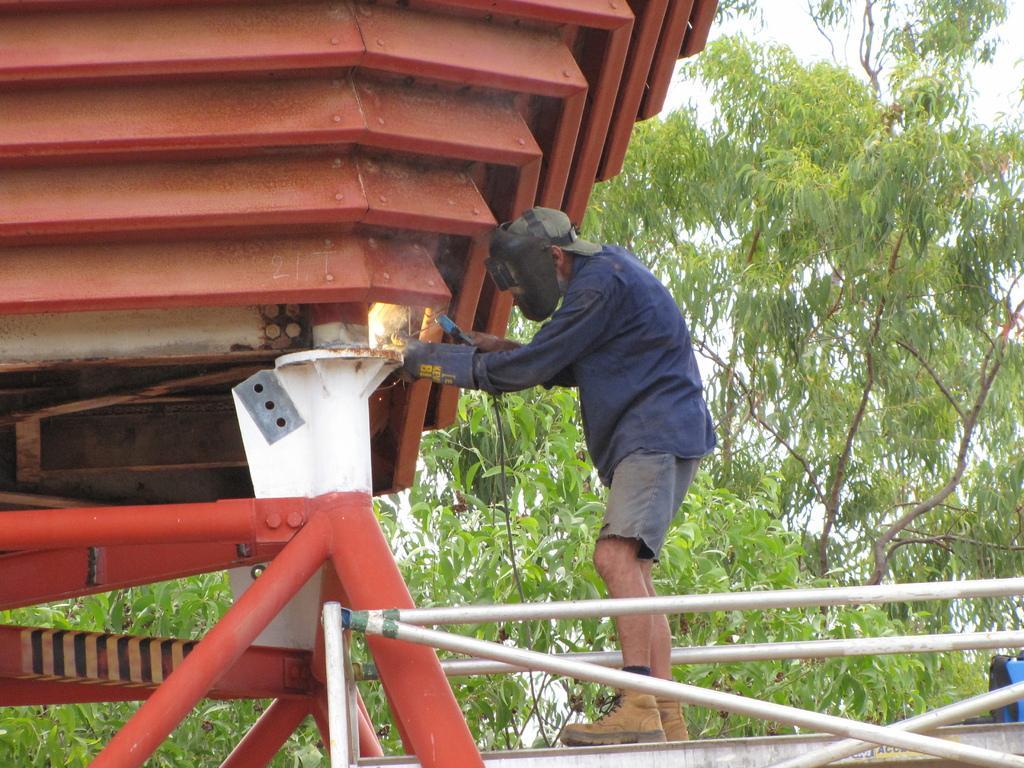Please provide a concise description of this image. In this image I can see a person wearing a helmet and holding an object in his hand. I can see few metal rods, and a red colored metal object. In the background, I can see few trees and the sky. 